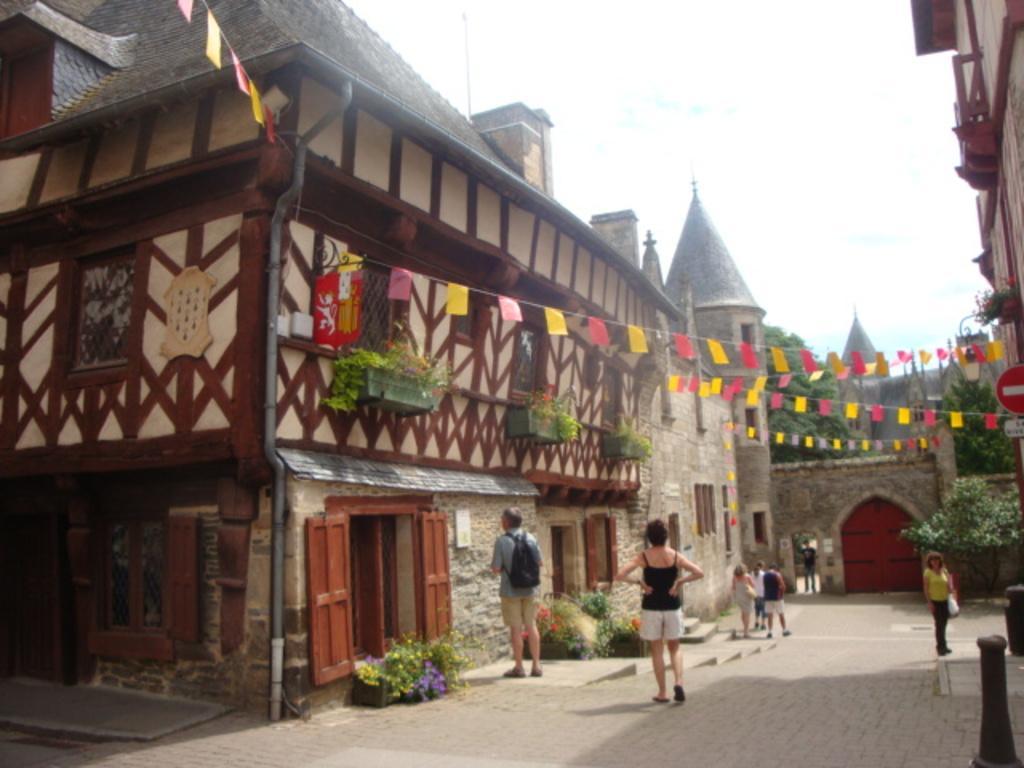Can you describe this image briefly? In this image, we can see people and some of them are wearing bags. In the background, there are buildings, flags, trees, flower pots and we can see a gate and some poles. At the top, there is sky and at the bottom, there is a road. 